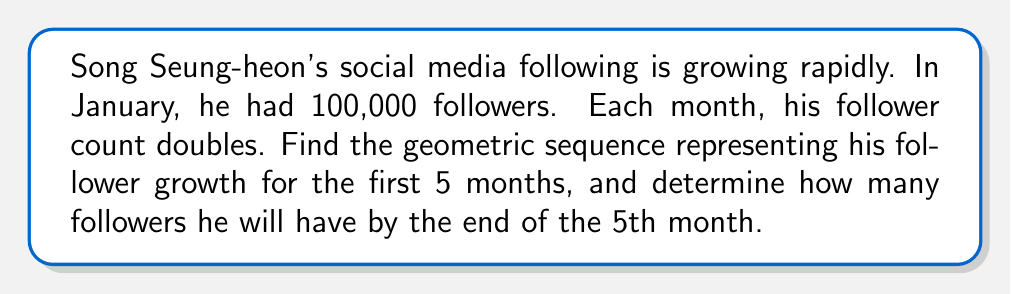What is the answer to this math problem? Let's approach this step-by-step:

1) In a geometric sequence, each term is found by multiplying the previous term by a constant, called the common ratio.

2) Given:
   - Initial number of followers (January): $a_1 = 100,000$
   - The follower count doubles each month, so the common ratio is $r = 2$

3) The general term of a geometric sequence is given by:
   $a_n = a_1 \cdot r^{n-1}$, where $a_n$ is the nth term, $a_1$ is the first term, $r$ is the common ratio, and $n$ is the term number.

4) Let's calculate the first 5 terms:
   
   January (1st month): $a_1 = 100,000$
   February (2nd month): $a_2 = 100,000 \cdot 2^{2-1} = 200,000$
   March (3rd month): $a_3 = 100,000 \cdot 2^{3-1} = 400,000$
   April (4th month): $a_4 = 100,000 \cdot 2^{4-1} = 800,000$
   May (5th month): $a_5 = 100,000 \cdot 2^{5-1} = 1,600,000$

5) The geometric sequence is: 
   $$(100,000, 200,000, 400,000, 800,000, 1,600,000)$$

6) By the end of the 5th month (May), Song Seung-heon will have 1,600,000 followers.
Answer: $(100,000, 200,000, 400,000, 800,000, 1,600,000)$; 1,600,000 followers 